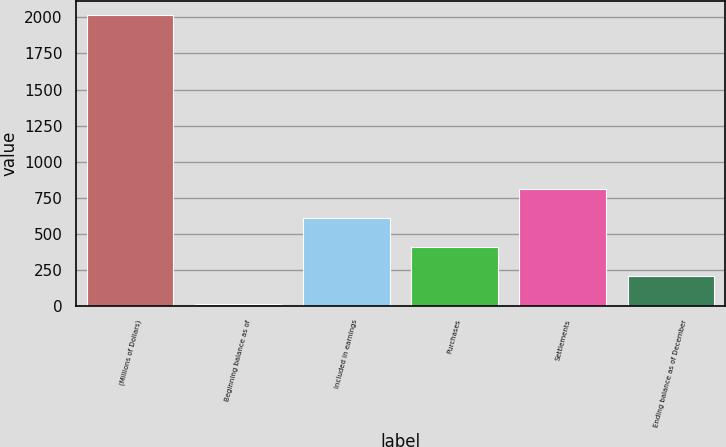Convert chart to OTSL. <chart><loc_0><loc_0><loc_500><loc_500><bar_chart><fcel>(Millions of Dollars)<fcel>Beginning balance as of<fcel>Included in earnings<fcel>Purchases<fcel>Settlements<fcel>Ending balance as of December<nl><fcel>2014<fcel>9<fcel>610.5<fcel>410<fcel>811<fcel>209.5<nl></chart> 